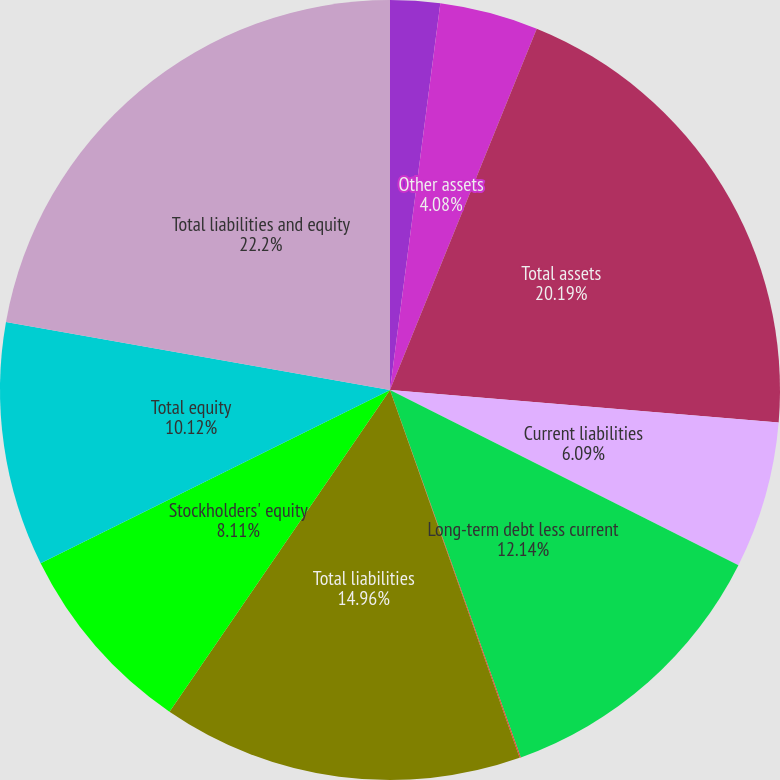Convert chart. <chart><loc_0><loc_0><loc_500><loc_500><pie_chart><fcel>Current assets<fcel>Other assets<fcel>Total assets<fcel>Current liabilities<fcel>Long-term debt less current<fcel>Other liabilities<fcel>Total liabilities<fcel>Stockholders' equity<fcel>Total equity<fcel>Total liabilities and equity<nl><fcel>2.06%<fcel>4.08%<fcel>20.19%<fcel>6.09%<fcel>12.14%<fcel>0.05%<fcel>14.96%<fcel>8.11%<fcel>10.12%<fcel>22.21%<nl></chart> 